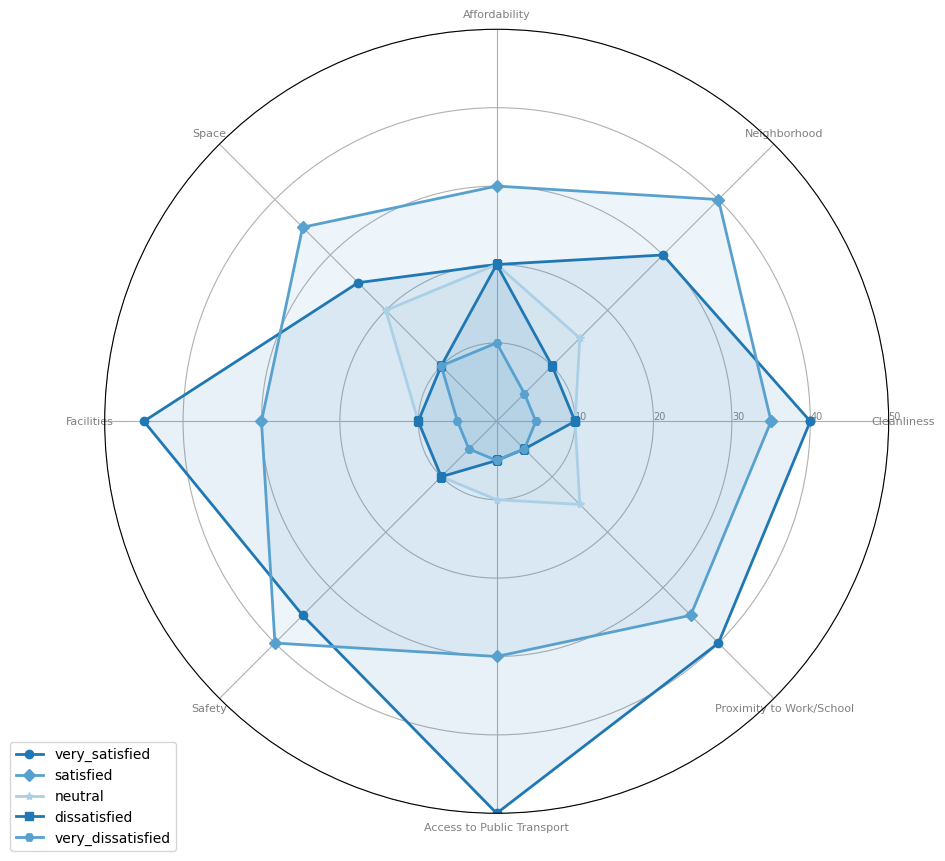Which category has the highest "very satisfied" rating? The "very satisfied" rating is represented by different plotted areas in the radar chart. The highest-rated category is "Access to Public Transport" with a score of 50.
Answer: Access to Public Transport Which category has the lowest satisfaction ratings overall? To find the lowest satisfaction ratings, we can observe and compare the total lengths of the plotted areas for all categories. "Affordability" has the lowest with considerable low ratings in both "very satisfied" and "satisfied", and higher in "dissatisfied" and "very dissatisfied".
Answer: Affordability How many categories have a "very satisfied" score of 40 or higher? Check each category's "very satisfied" score plotted on the radar chart. Categories "Cleanliness", "Facilities", "Safety", "Access to Public Transport", and "Proximity to Work/School" have scores of 40 or higher. There are 5 such categories.
Answer: 5 Which category has the highest combined score of "satisfied" and "very satisfied"? Add the "satisfied" and "very satisfied" values for each category. "Access to Public Transport" has the combined score of 50 + 30 = 80, which is the highest.
Answer: Access to Public Transport Which two categories have equal "very dissatisfied" ratings? Comparing the "very dissatisfied" ratings across categories, "Cleanliness", "Neighborhood", "Facilities", "Safety", "Access to Public Transport", and "Proximity to Work/School" all have equal ratings of 5.
Answer: Cleanliness and Neighborhood (among others) Calculate the average "neutral" satisfaction score across all categories. Sum up the "neutral" scores for all categories (10 + 15 + 20 + 20 + 10 + 10 + 10 + 15 = 110) and divide by the number of categories (8). The average score is 110 / 8 = 13.75.
Answer: 13.75 Which categories have a "dissatisfied" score greater than 15? Check the "dissatisfied" ratings on the radar chart. Only "Affordability" has a "dissatisfied" score greater than 15, which is 20.
Answer: Affordability Is the "satisfied" rating for "Space" greater than, less than, or equal to the "satisfied" rating for "Cleanliness"? Compare the "satisfied" rating for "Space" (35) to that for "Cleanliness" (35). They are equal.
Answer: Equal In how many categories is the "very dissatisfied" score exactly 5? Count the categories with "very dissatisfied" ratings of exactly 5. The categories are "Cleanliness", "Neighborhood", "Facilities", "Safety", "Access to Public Transport", and "Proximity to Work/School". There are 6 categories in total.
Answer: 6 